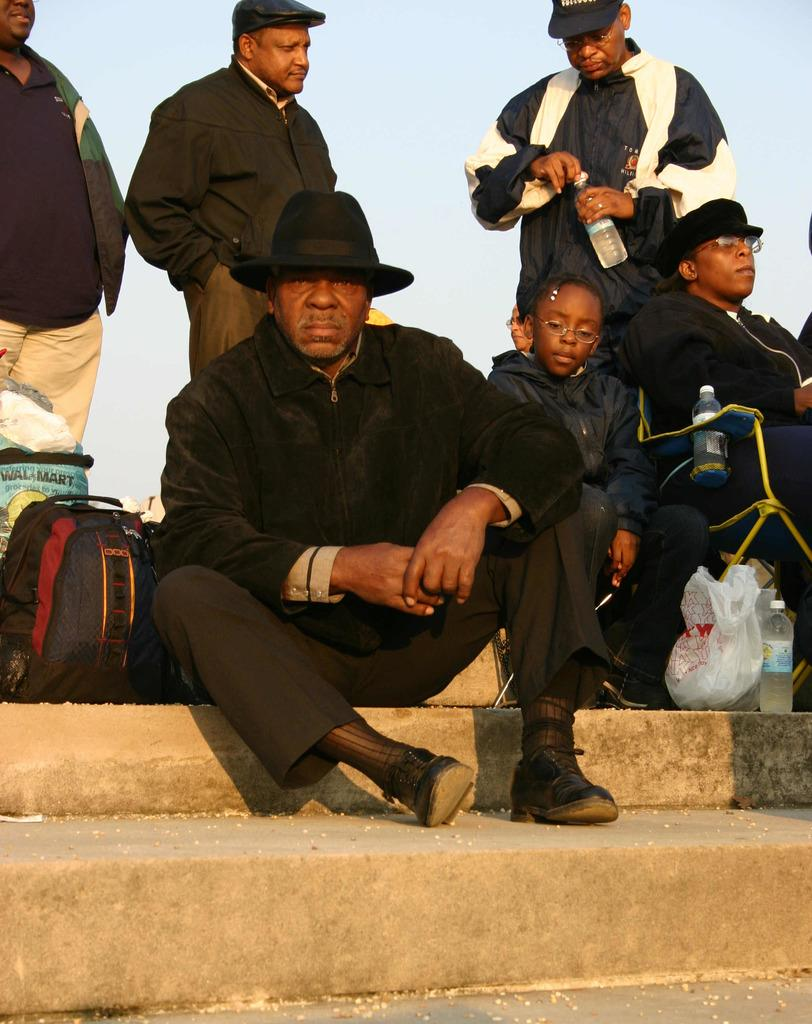What are the people in the image doing? There are people sitting and standing in the image. What items can be seen for hydration in the image? Water bottles are visible in the image. What type of bag is present in the image? There is a bag and a cover bag in the image. What can be seen in the background of the image? The sky is visible in the background of the image. What type of whip can be seen in the image? There is no whip present in the image. What type of skirt is worn by the people in the image? The clothing of the people in the image cannot be determined from the provided facts. 